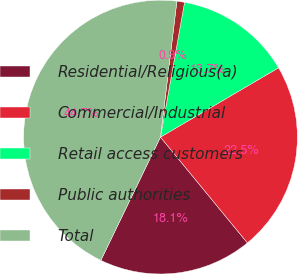Convert chart to OTSL. <chart><loc_0><loc_0><loc_500><loc_500><pie_chart><fcel>Residential/Religious(a)<fcel>Commercial/Industrial<fcel>Retail access customers<fcel>Public authorities<fcel>Total<nl><fcel>18.12%<fcel>22.5%<fcel>13.74%<fcel>0.9%<fcel>44.74%<nl></chart> 